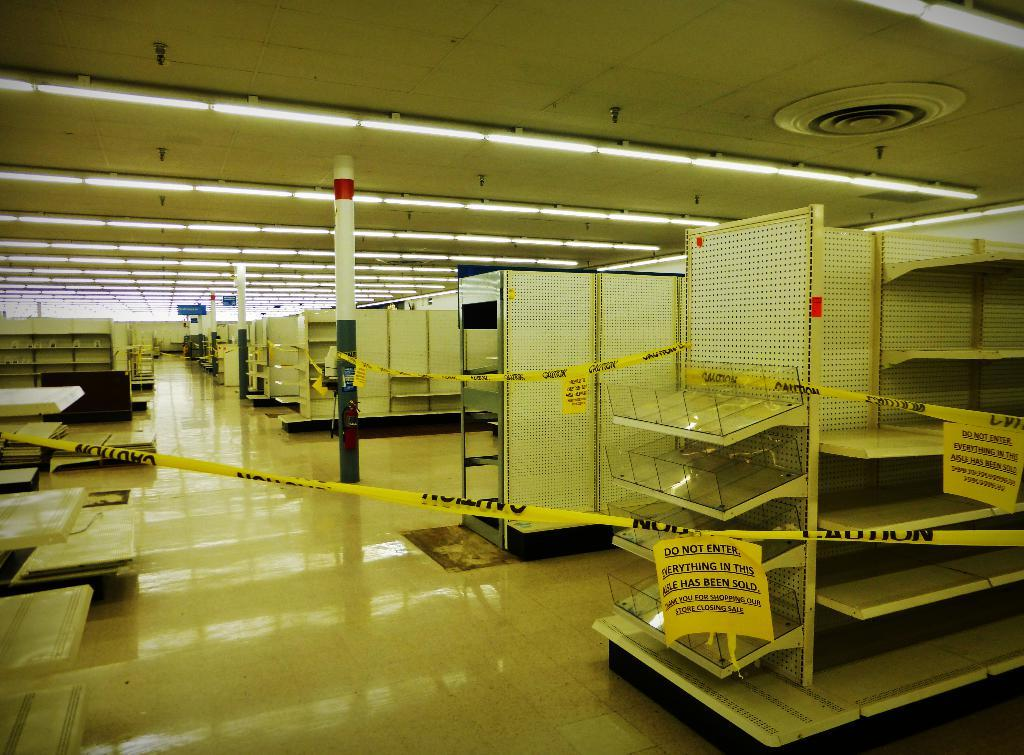What can be seen in the foreground of the image? There are racks and posters in the foreground of the image. What else can be seen in the background of the image? There are racks and lamps in the background of the image. What type of soda is being advertised on the rail in the image? There is no rail or soda present in the image. Can you tell me how many toys are on the racks in the image? There are no toys present on the racks in the image. 